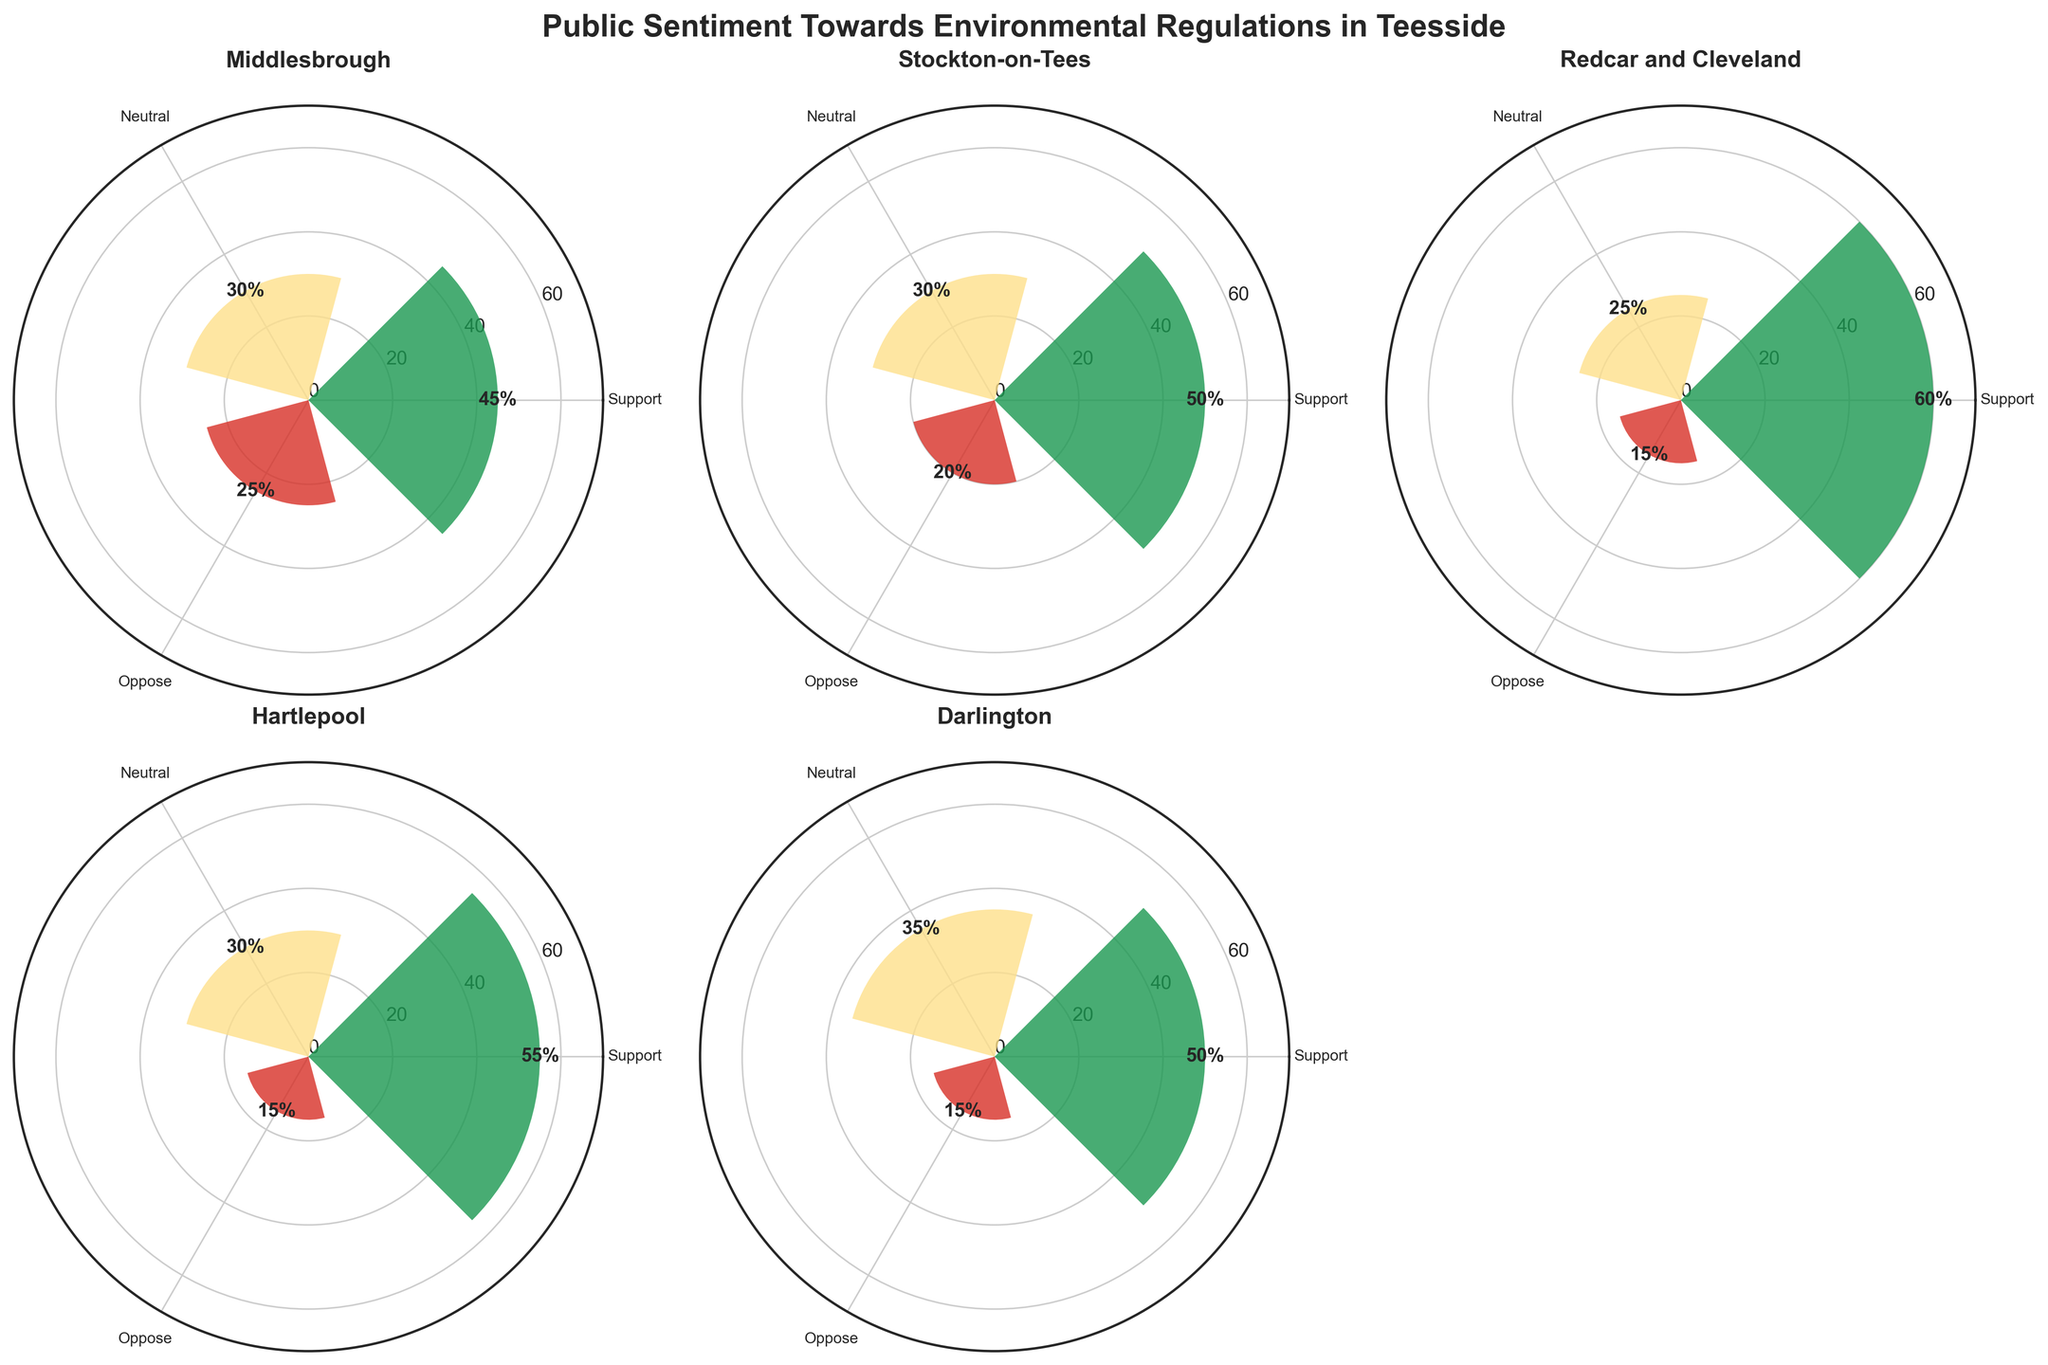Which borough shows the highest support for environmental regulations? The plot shows different support levels with distinct radial lengths. The one with the largest radial length for support is Redcar and Cleveland.
Answer: Redcar and Cleveland Which borough has the greatest percentage of people opposing environmental regulations? Oppose is represented by the red sections of the bars. Middlesbrough's opposition section extends furthest outwards.
Answer: Middlesbrough What is the average support percentage across all boroughs? Add the support percentages (45 + 50 + 60 + 55 + 50) and divide by the number of boroughs (5), (45+50+60+55+50) / 5.
Answer: 52 Which borough has the highest percentage of neutral sentiment towards environmental regulations? Neutral sections are colored yellow. Darlington has the longest yellow section.
Answer: Darlington How does the support for environmental regulations in Stockton-on-Tees compare to Middlesbrough? Compare the green sections of the bars for both boroughs. Stockton-on-Tees has 50% support, whereas Middlesbrough has 45%.
Answer: Stockton-on-Tees has 5% more support Which borough has the lowest neutral sentiment percentage towards environmental regulations? Find the smallest yellow section. Redcar and Cleveland has the shortest yellow bar.
Answer: Redcar and Cleveland What is the total percentage for neutral sentiment in Redcar and Cleveland and Hartlepool combined? Redcar and Cleveland has 25% and Hartlepool has 30%. Add these values together: 25 + 30.
Answer: 55 Which borough has the smallest disparity between support and oppose percentages? Calculate the absolute difference between support and oppose for each borough. Middlesbrough: 20%, Stockton-on-Tees: 30%, Redcar and Cleveland: 45%, Hartlepool: 40%, Darlington: 35%.
Answer: Middlesbrough How many boroughs have a higher percentage of support than the average across all boroughs? Compare each borough's support to the average support of 52%. Only Redcar and Cleveland (60%) and Hartlepool (55%) exceed this average.
Answer: 2 Which borough has equal percentages for neutral sentiment and opposing environmental regulations? Compare neutral and opposing sections. Middlesbrough has 30% neutral and 25% opposition, Hartlepool has 30% neutral and 15% opposition, only Darlington has equal percentages (35% neutral and 35% opposition).
Answer: None 